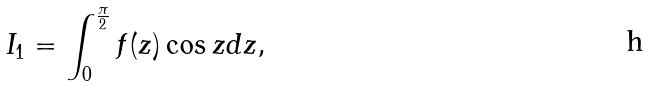<formula> <loc_0><loc_0><loc_500><loc_500>I _ { 1 } = \int ^ { \frac { \pi } { 2 } } _ { 0 } f ( z ) \cos z d z ,</formula> 